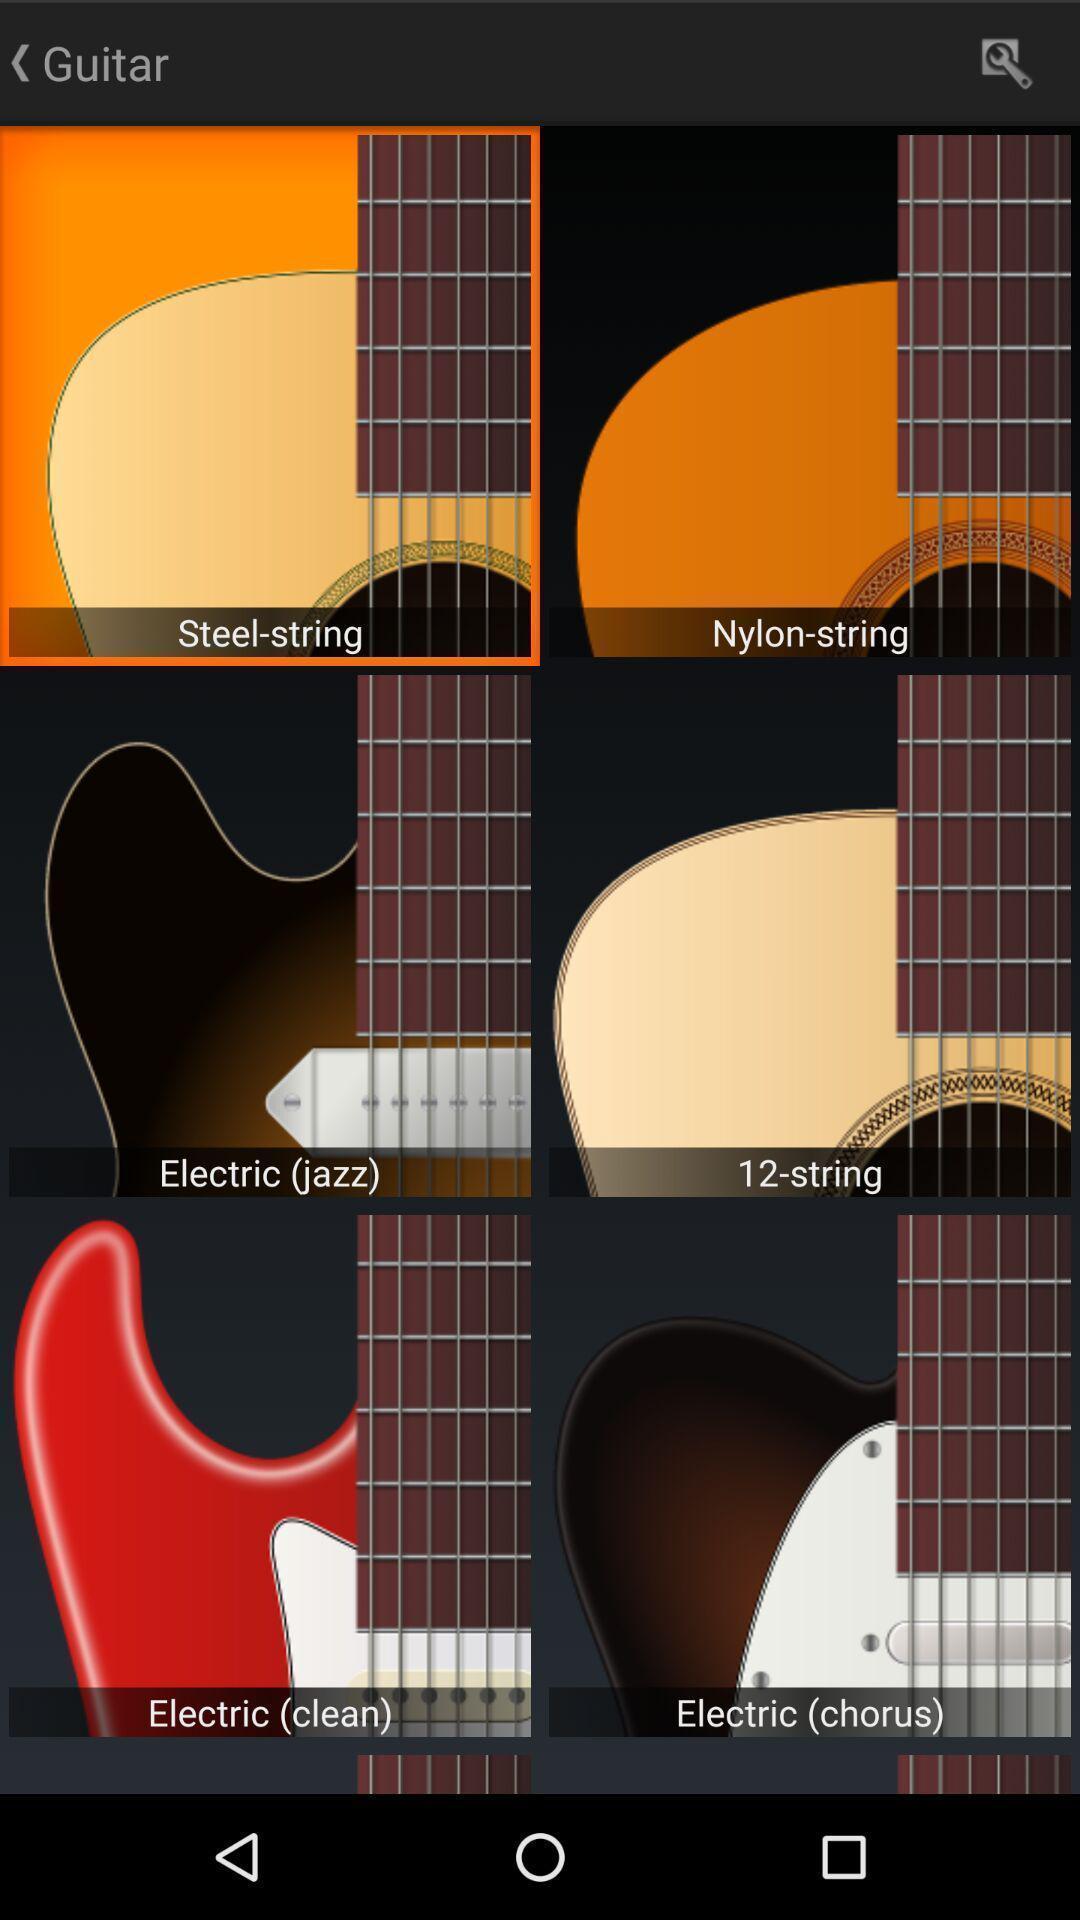What details can you identify in this image? Various types of guitars in the mobile. 